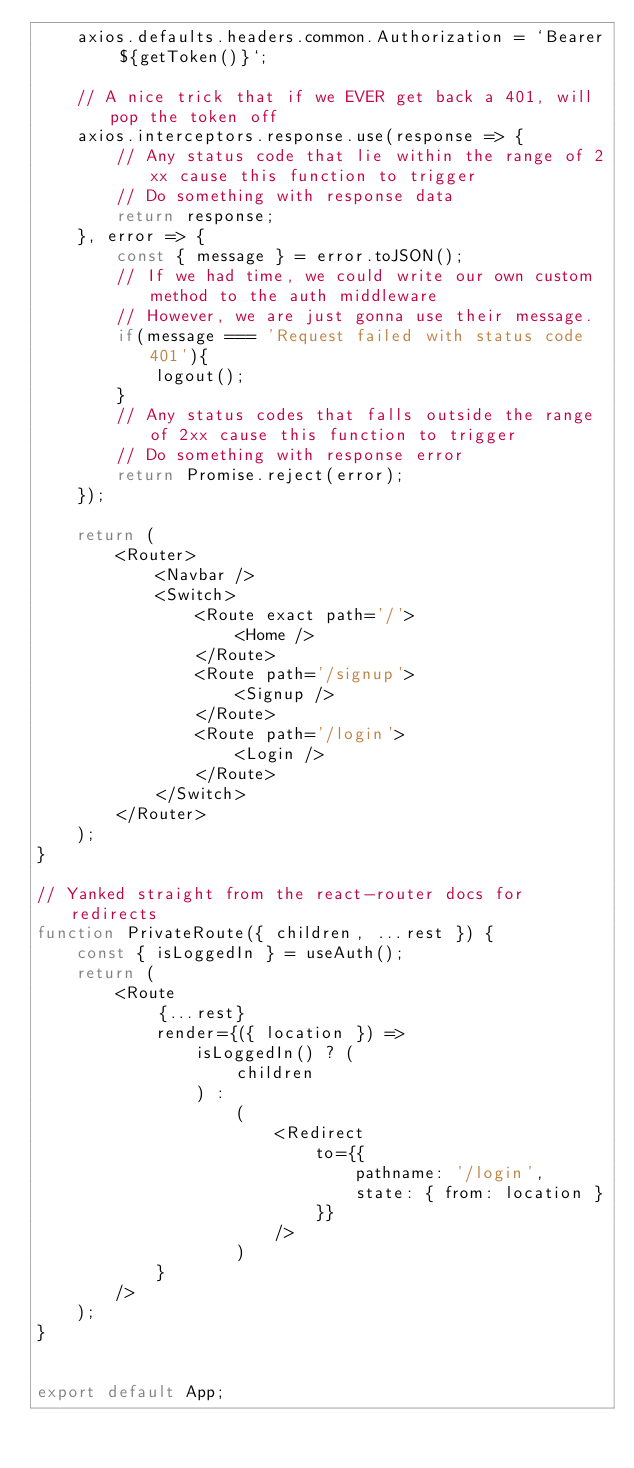<code> <loc_0><loc_0><loc_500><loc_500><_JavaScript_>    axios.defaults.headers.common.Authorization = `Bearer ${getToken()}`;

    // A nice trick that if we EVER get back a 401, will pop the token off
    axios.interceptors.response.use(response => {
        // Any status code that lie within the range of 2xx cause this function to trigger
        // Do something with response data
        return response;
    }, error => {
        const { message } = error.toJSON();
        // If we had time, we could write our own custom method to the auth middleware
        // However, we are just gonna use their message.
        if(message === 'Request failed with status code 401'){
            logout();
        }
        // Any status codes that falls outside the range of 2xx cause this function to trigger
        // Do something with response error
        return Promise.reject(error);
    });
    
    return (
        <Router>
            <Navbar />
            <Switch>
                <Route exact path='/'>
                    <Home />
                </Route>
                <Route path='/signup'>
                    <Signup />
                </Route>
                <Route path='/login'>
                    <Login />
                </Route>
            </Switch>
        </Router>
    );
}

// Yanked straight from the react-router docs for redirects
function PrivateRoute({ children, ...rest }) {
    const { isLoggedIn } = useAuth();
    return (
        <Route
            {...rest}
            render={({ location }) =>
                isLoggedIn() ? (
                    children
                ) :
                    (
                        <Redirect
                            to={{
                                pathname: '/login',
                                state: { from: location }
                            }}
                        />
                    )
            }
        />
    );
}


export default App;
</code> 